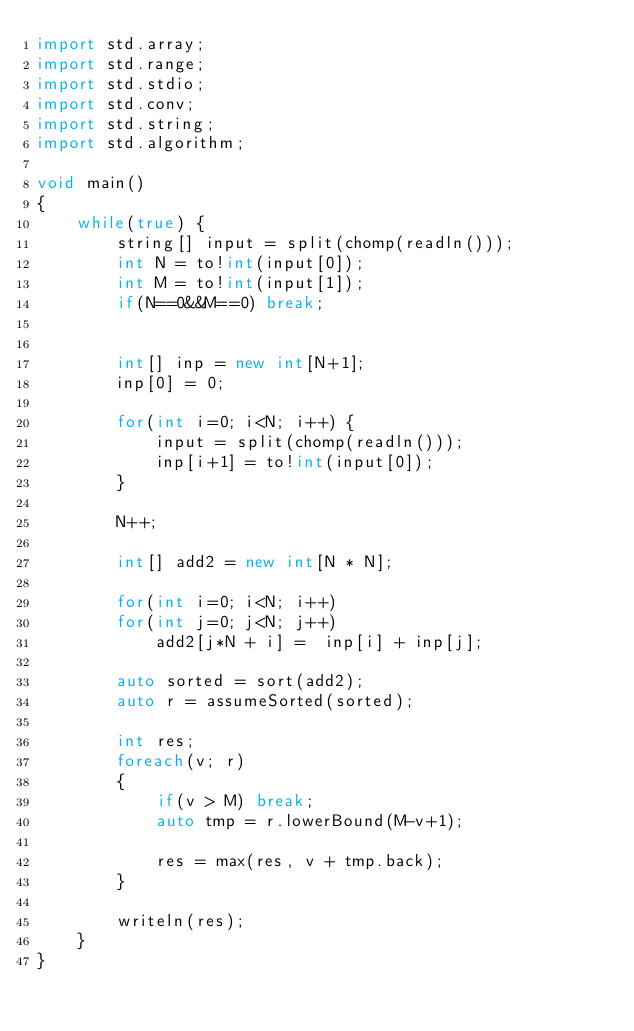<code> <loc_0><loc_0><loc_500><loc_500><_D_>import std.array;
import std.range;
import std.stdio;
import std.conv;
import std.string;
import std.algorithm;

void main()
{
	while(true) {
		string[] input = split(chomp(readln()));	
		int N = to!int(input[0]);
		int M = to!int(input[1]);
		if(N==0&&M==0) break;
		

		int[] inp = new int[N+1];
		inp[0] = 0;

		for(int i=0; i<N; i++) {
			input = split(chomp(readln()));
			inp[i+1] = to!int(input[0]);
		}

		N++;

		int[] add2 = new int[N * N];

		for(int i=0; i<N; i++)
		for(int j=0; j<N; j++)
			add2[j*N + i] =  inp[i] + inp[j];
	
		auto sorted = sort(add2);
		auto r = assumeSorted(sorted);

		int res;
		foreach(v; r)
		{
			if(v > M) break;
			auto tmp = r.lowerBound(M-v+1);

			res = max(res, v + tmp.back);
		}

		writeln(res);
	}
}</code> 